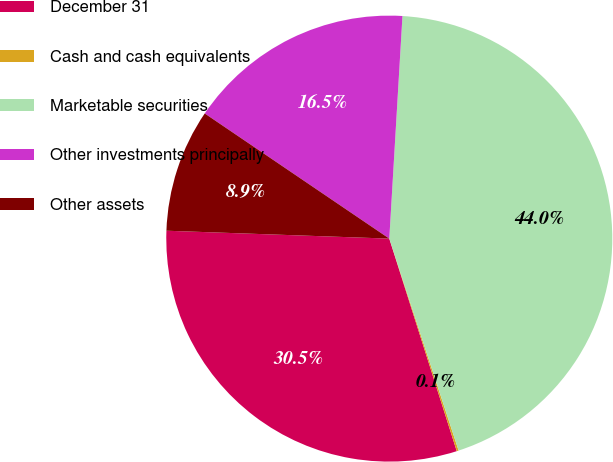<chart> <loc_0><loc_0><loc_500><loc_500><pie_chart><fcel>December 31<fcel>Cash and cash equivalents<fcel>Marketable securities<fcel>Other investments principally<fcel>Other assets<nl><fcel>30.46%<fcel>0.14%<fcel>44.03%<fcel>16.46%<fcel>8.92%<nl></chart> 